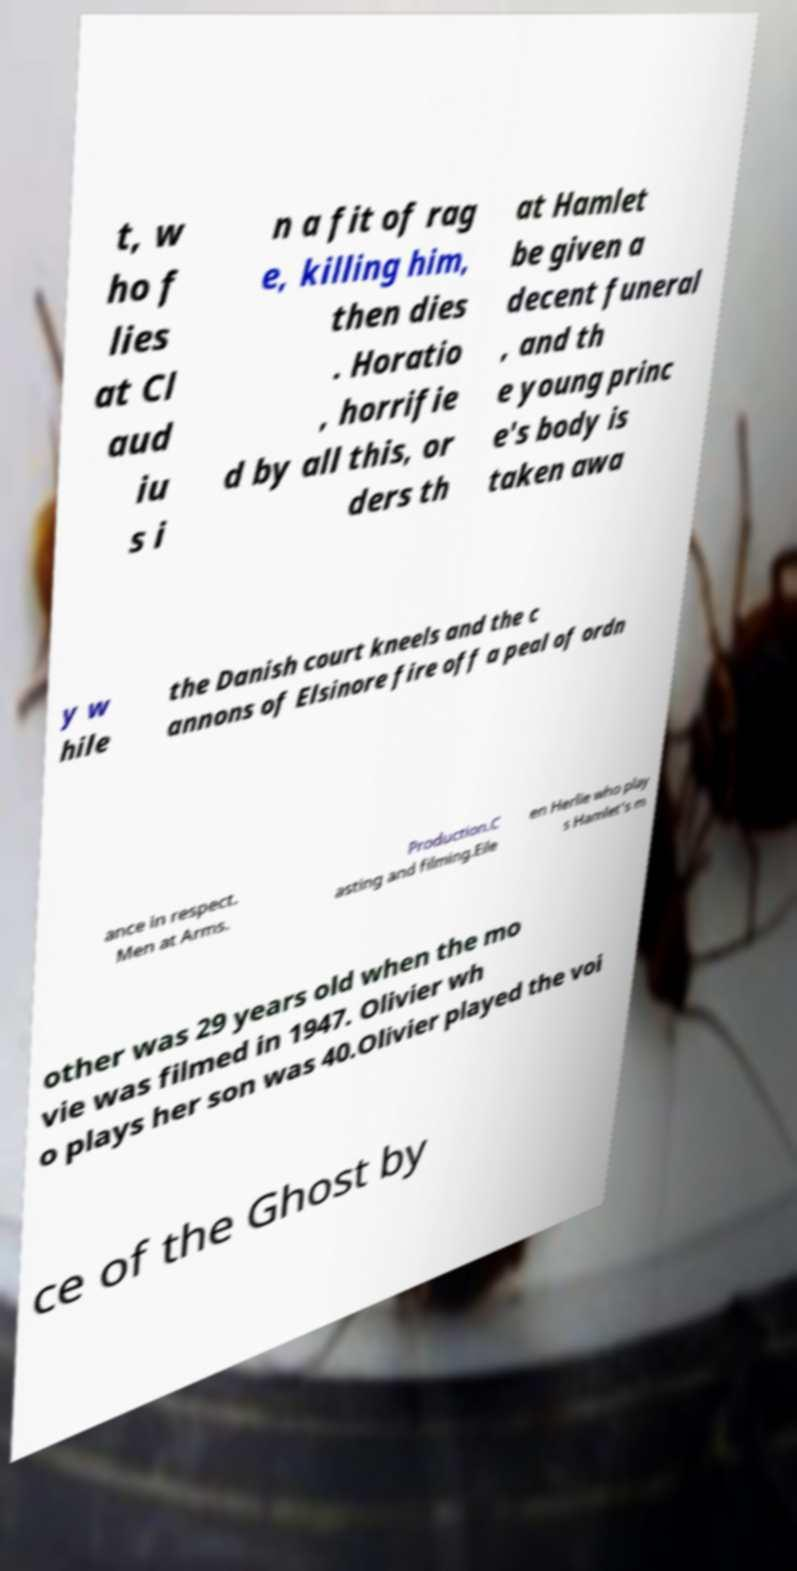Could you assist in decoding the text presented in this image and type it out clearly? t, w ho f lies at Cl aud iu s i n a fit of rag e, killing him, then dies . Horatio , horrifie d by all this, or ders th at Hamlet be given a decent funeral , and th e young princ e's body is taken awa y w hile the Danish court kneels and the c annons of Elsinore fire off a peal of ordn ance in respect. Men at Arms. Production.C asting and filming.Eile en Herlie who play s Hamlet's m other was 29 years old when the mo vie was filmed in 1947. Olivier wh o plays her son was 40.Olivier played the voi ce of the Ghost by 